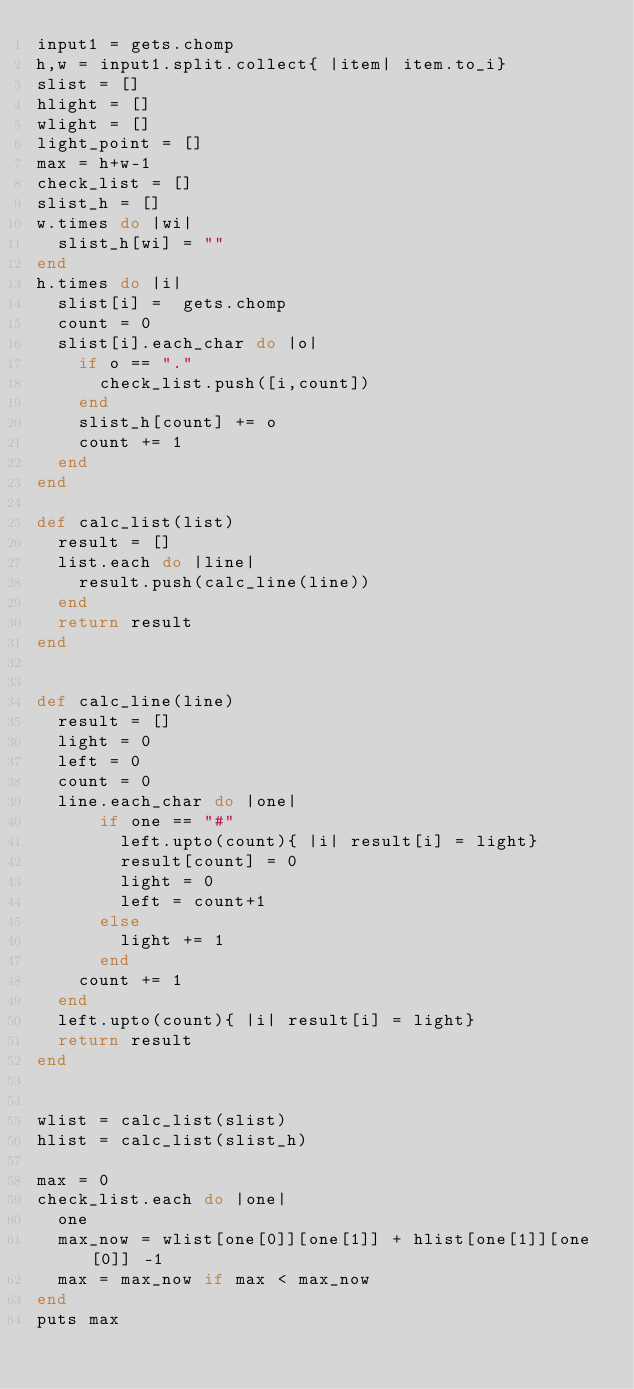<code> <loc_0><loc_0><loc_500><loc_500><_Ruby_>input1 = gets.chomp
h,w = input1.split.collect{ |item| item.to_i}
slist = []
hlight = []
wlight = []
light_point = []
max = h+w-1
check_list = []
slist_h = []
w.times do |wi|
  slist_h[wi] = ""
end
h.times do |i|
  slist[i] =  gets.chomp
  count = 0
  slist[i].each_char do |o|
    if o == "."
      check_list.push([i,count])
    end
    slist_h[count] += o
    count += 1
  end
end

def calc_list(list)
  result = []
  list.each do |line|
    result.push(calc_line(line))
  end
  return result
end


def calc_line(line)
  result = []
  light = 0
  left = 0
  count = 0
  line.each_char do |one|
      if one == "#"
        left.upto(count){ |i| result[i] = light}
        result[count] = 0
        light = 0
        left = count+1
      else
        light += 1
      end
    count += 1
  end
  left.upto(count){ |i| result[i] = light}
  return result
end


wlist = calc_list(slist)
hlist = calc_list(slist_h)

max = 0
check_list.each do |one|
  one
  max_now = wlist[one[0]][one[1]] + hlist[one[1]][one[0]] -1
  max = max_now if max < max_now
end
puts max

</code> 